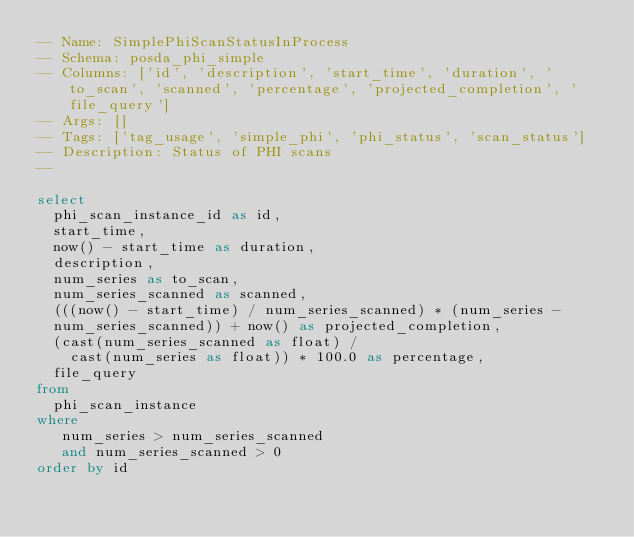<code> <loc_0><loc_0><loc_500><loc_500><_SQL_>-- Name: SimplePhiScanStatusInProcess
-- Schema: posda_phi_simple
-- Columns: ['id', 'description', 'start_time', 'duration', 'to_scan', 'scanned', 'percentage', 'projected_completion', 'file_query']
-- Args: []
-- Tags: ['tag_usage', 'simple_phi', 'phi_status', 'scan_status']
-- Description: Status of PHI scans
-- 

select
  phi_scan_instance_id as id,
  start_time,
  now() - start_time as duration,
  description,
  num_series as to_scan,
  num_series_scanned as scanned,
  (((now() - start_time) / num_series_scanned) * (num_series -
  num_series_scanned)) + now() as projected_completion,
  (cast(num_series_scanned as float) / 
    cast(num_series as float)) * 100.0 as percentage,
  file_query
from
  phi_scan_instance
where
   num_series > num_series_scanned
   and num_series_scanned > 0
order by id
</code> 